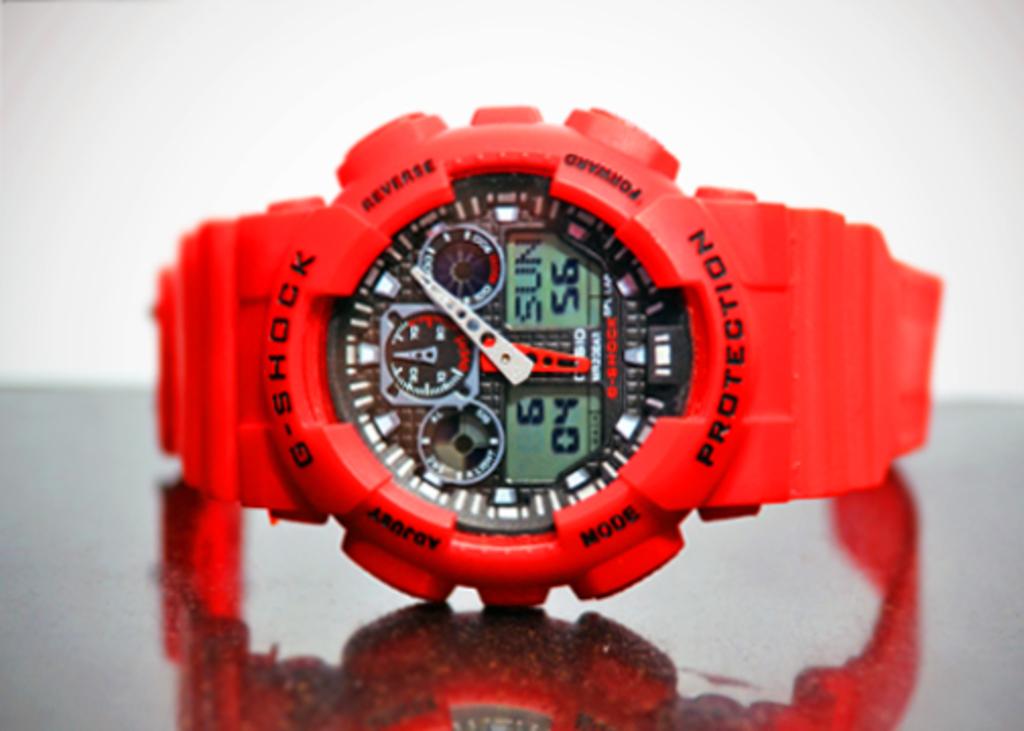What kind of protection does this watch have?
Your answer should be compact. G-shock. What is that green board saying?
Your answer should be compact. Sun. 